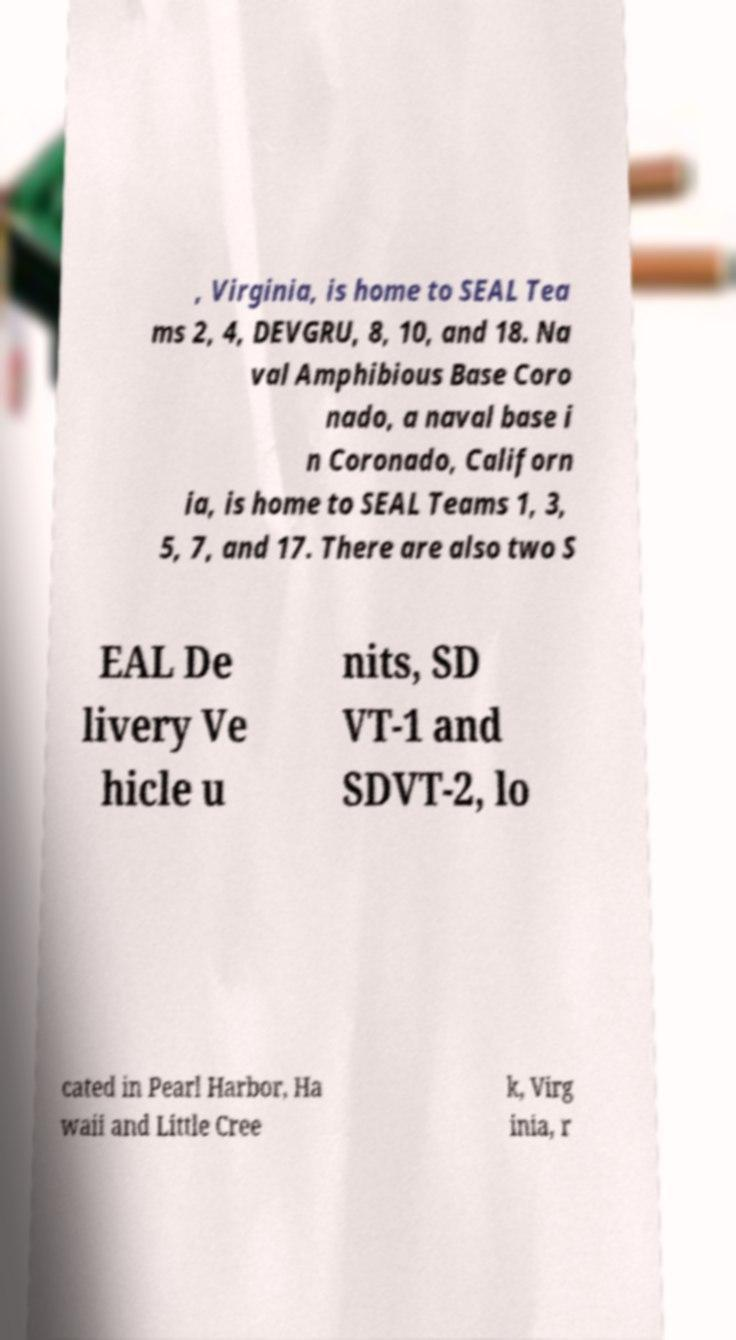There's text embedded in this image that I need extracted. Can you transcribe it verbatim? , Virginia, is home to SEAL Tea ms 2, 4, DEVGRU, 8, 10, and 18. Na val Amphibious Base Coro nado, a naval base i n Coronado, Californ ia, is home to SEAL Teams 1, 3, 5, 7, and 17. There are also two S EAL De livery Ve hicle u nits, SD VT-1 and SDVT-2, lo cated in Pearl Harbor, Ha waii and Little Cree k, Virg inia, r 